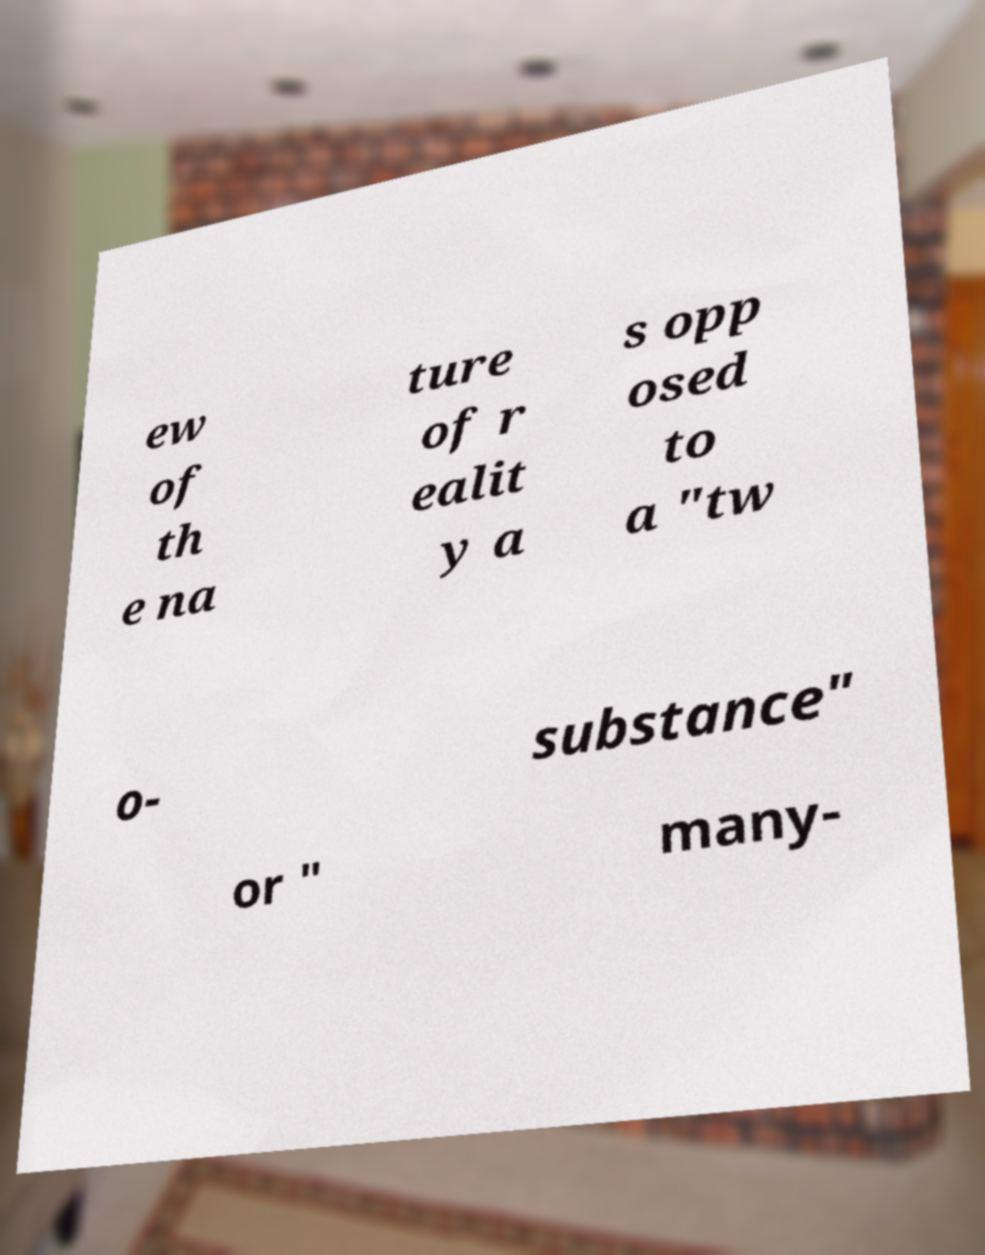I need the written content from this picture converted into text. Can you do that? ew of th e na ture of r ealit y a s opp osed to a "tw o- substance" or " many- 